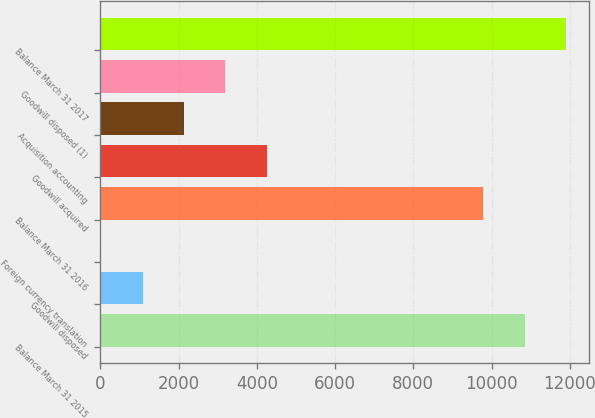Convert chart. <chart><loc_0><loc_0><loc_500><loc_500><bar_chart><fcel>Balance March 31 2015<fcel>Goodwill disposed<fcel>Foreign currency translation<fcel>Balance March 31 2016<fcel>Goodwill acquired<fcel>Acquisition accounting<fcel>Goodwill disposed (1)<fcel>Balance March 31 2017<nl><fcel>10842<fcel>1082<fcel>26<fcel>9786<fcel>4250<fcel>2138<fcel>3194<fcel>11898<nl></chart> 